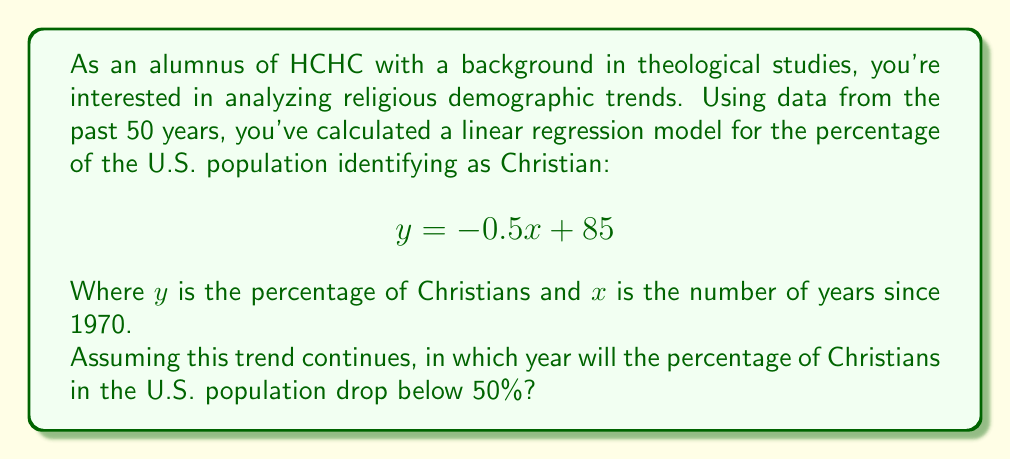Solve this math problem. To solve this problem, we need to use the given linear regression model and extrapolate to find when the percentage will drop below 50%. Let's approach this step-by-step:

1) The linear regression model is given as:
   $$y = -0.5x + 85$$
   Where $y$ is the percentage of Christians and $x$ is the number of years since 1970.

2) We want to find when $y$ will be less than 50%. So, we set up the inequality:
   $$-0.5x + 85 < 50$$

3) Solve the inequality:
   $$-0.5x < -35$$
   $$x > 70$$

4) This means that the percentage will drop below 50% when $x$ is greater than 70 years after 1970.

5) To find the actual year, we add 70 to 1970:
   $$1970 + 70 = 2040$$

6) Therefore, the percentage will drop below 50% in 2041, as 2040 is the last year it will be at or above 50%.

This extrapolation assumes the linear trend continues, which may not be accurate over long periods. Religious demographics can be influenced by various factors not captured in this simple model.
Answer: 2041 